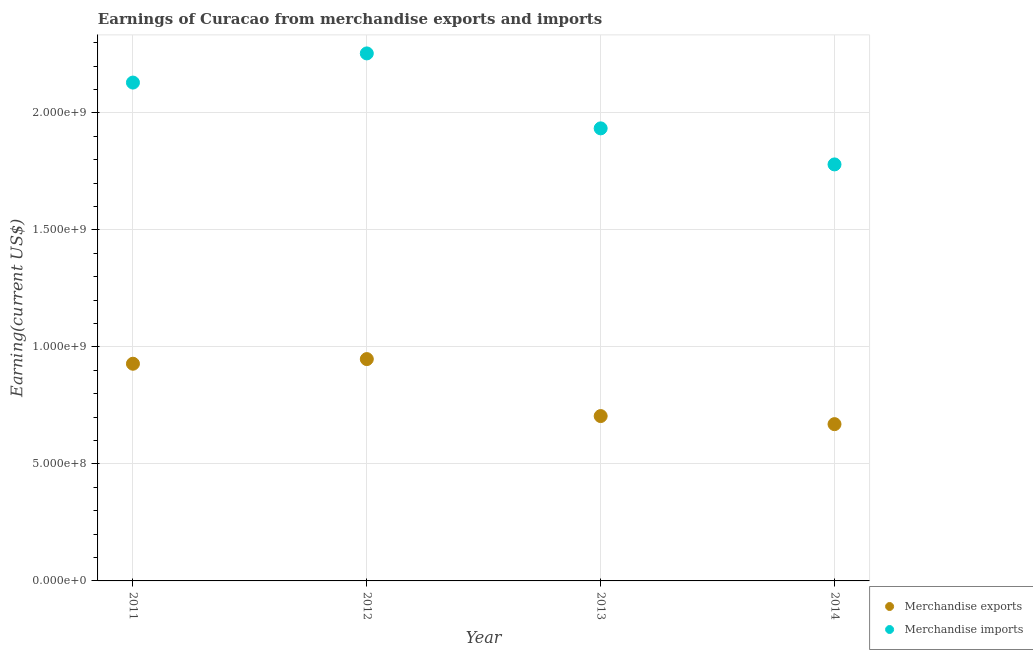What is the earnings from merchandise imports in 2012?
Your answer should be compact. 2.25e+09. Across all years, what is the maximum earnings from merchandise imports?
Make the answer very short. 2.25e+09. Across all years, what is the minimum earnings from merchandise exports?
Provide a succinct answer. 6.70e+08. In which year was the earnings from merchandise imports maximum?
Give a very brief answer. 2012. In which year was the earnings from merchandise imports minimum?
Offer a very short reply. 2014. What is the total earnings from merchandise imports in the graph?
Offer a terse response. 8.10e+09. What is the difference between the earnings from merchandise imports in 2012 and that in 2013?
Your answer should be very brief. 3.20e+08. What is the difference between the earnings from merchandise imports in 2014 and the earnings from merchandise exports in 2013?
Your answer should be very brief. 1.08e+09. What is the average earnings from merchandise imports per year?
Ensure brevity in your answer.  2.02e+09. In the year 2013, what is the difference between the earnings from merchandise imports and earnings from merchandise exports?
Offer a very short reply. 1.23e+09. What is the ratio of the earnings from merchandise imports in 2011 to that in 2012?
Give a very brief answer. 0.94. What is the difference between the highest and the second highest earnings from merchandise imports?
Ensure brevity in your answer.  1.25e+08. What is the difference between the highest and the lowest earnings from merchandise exports?
Keep it short and to the point. 2.78e+08. Does the earnings from merchandise exports monotonically increase over the years?
Keep it short and to the point. No. Is the earnings from merchandise exports strictly greater than the earnings from merchandise imports over the years?
Your response must be concise. No. How many years are there in the graph?
Provide a short and direct response. 4. What is the difference between two consecutive major ticks on the Y-axis?
Provide a short and direct response. 5.00e+08. Are the values on the major ticks of Y-axis written in scientific E-notation?
Your answer should be very brief. Yes. Does the graph contain any zero values?
Provide a succinct answer. No. Does the graph contain grids?
Provide a succinct answer. Yes. What is the title of the graph?
Your answer should be very brief. Earnings of Curacao from merchandise exports and imports. What is the label or title of the Y-axis?
Make the answer very short. Earning(current US$). What is the Earning(current US$) in Merchandise exports in 2011?
Make the answer very short. 9.28e+08. What is the Earning(current US$) of Merchandise imports in 2011?
Offer a very short reply. 2.13e+09. What is the Earning(current US$) in Merchandise exports in 2012?
Ensure brevity in your answer.  9.48e+08. What is the Earning(current US$) of Merchandise imports in 2012?
Keep it short and to the point. 2.25e+09. What is the Earning(current US$) of Merchandise exports in 2013?
Your answer should be very brief. 7.05e+08. What is the Earning(current US$) of Merchandise imports in 2013?
Your response must be concise. 1.93e+09. What is the Earning(current US$) of Merchandise exports in 2014?
Your answer should be very brief. 6.70e+08. What is the Earning(current US$) in Merchandise imports in 2014?
Provide a short and direct response. 1.78e+09. Across all years, what is the maximum Earning(current US$) of Merchandise exports?
Keep it short and to the point. 9.48e+08. Across all years, what is the maximum Earning(current US$) in Merchandise imports?
Provide a succinct answer. 2.25e+09. Across all years, what is the minimum Earning(current US$) of Merchandise exports?
Your response must be concise. 6.70e+08. Across all years, what is the minimum Earning(current US$) in Merchandise imports?
Offer a very short reply. 1.78e+09. What is the total Earning(current US$) in Merchandise exports in the graph?
Your answer should be compact. 3.25e+09. What is the total Earning(current US$) of Merchandise imports in the graph?
Your answer should be compact. 8.10e+09. What is the difference between the Earning(current US$) in Merchandise exports in 2011 and that in 2012?
Provide a short and direct response. -1.99e+07. What is the difference between the Earning(current US$) of Merchandise imports in 2011 and that in 2012?
Provide a succinct answer. -1.25e+08. What is the difference between the Earning(current US$) in Merchandise exports in 2011 and that in 2013?
Your answer should be very brief. 2.24e+08. What is the difference between the Earning(current US$) of Merchandise imports in 2011 and that in 2013?
Your answer should be compact. 1.96e+08. What is the difference between the Earning(current US$) in Merchandise exports in 2011 and that in 2014?
Provide a short and direct response. 2.58e+08. What is the difference between the Earning(current US$) in Merchandise imports in 2011 and that in 2014?
Provide a short and direct response. 3.50e+08. What is the difference between the Earning(current US$) in Merchandise exports in 2012 and that in 2013?
Give a very brief answer. 2.44e+08. What is the difference between the Earning(current US$) of Merchandise imports in 2012 and that in 2013?
Keep it short and to the point. 3.20e+08. What is the difference between the Earning(current US$) in Merchandise exports in 2012 and that in 2014?
Your answer should be very brief. 2.78e+08. What is the difference between the Earning(current US$) of Merchandise imports in 2012 and that in 2014?
Give a very brief answer. 4.74e+08. What is the difference between the Earning(current US$) of Merchandise exports in 2013 and that in 2014?
Give a very brief answer. 3.45e+07. What is the difference between the Earning(current US$) in Merchandise imports in 2013 and that in 2014?
Your response must be concise. 1.54e+08. What is the difference between the Earning(current US$) in Merchandise exports in 2011 and the Earning(current US$) in Merchandise imports in 2012?
Offer a very short reply. -1.33e+09. What is the difference between the Earning(current US$) of Merchandise exports in 2011 and the Earning(current US$) of Merchandise imports in 2013?
Keep it short and to the point. -1.01e+09. What is the difference between the Earning(current US$) of Merchandise exports in 2011 and the Earning(current US$) of Merchandise imports in 2014?
Ensure brevity in your answer.  -8.52e+08. What is the difference between the Earning(current US$) in Merchandise exports in 2012 and the Earning(current US$) in Merchandise imports in 2013?
Give a very brief answer. -9.86e+08. What is the difference between the Earning(current US$) of Merchandise exports in 2012 and the Earning(current US$) of Merchandise imports in 2014?
Your answer should be compact. -8.32e+08. What is the difference between the Earning(current US$) in Merchandise exports in 2013 and the Earning(current US$) in Merchandise imports in 2014?
Your answer should be compact. -1.08e+09. What is the average Earning(current US$) in Merchandise exports per year?
Provide a short and direct response. 8.13e+08. What is the average Earning(current US$) in Merchandise imports per year?
Your answer should be compact. 2.02e+09. In the year 2011, what is the difference between the Earning(current US$) in Merchandise exports and Earning(current US$) in Merchandise imports?
Your response must be concise. -1.20e+09. In the year 2012, what is the difference between the Earning(current US$) of Merchandise exports and Earning(current US$) of Merchandise imports?
Your response must be concise. -1.31e+09. In the year 2013, what is the difference between the Earning(current US$) of Merchandise exports and Earning(current US$) of Merchandise imports?
Provide a short and direct response. -1.23e+09. In the year 2014, what is the difference between the Earning(current US$) in Merchandise exports and Earning(current US$) in Merchandise imports?
Your answer should be compact. -1.11e+09. What is the ratio of the Earning(current US$) of Merchandise imports in 2011 to that in 2012?
Provide a short and direct response. 0.94. What is the ratio of the Earning(current US$) in Merchandise exports in 2011 to that in 2013?
Provide a short and direct response. 1.32. What is the ratio of the Earning(current US$) in Merchandise imports in 2011 to that in 2013?
Offer a terse response. 1.1. What is the ratio of the Earning(current US$) of Merchandise exports in 2011 to that in 2014?
Your response must be concise. 1.39. What is the ratio of the Earning(current US$) of Merchandise imports in 2011 to that in 2014?
Give a very brief answer. 1.2. What is the ratio of the Earning(current US$) in Merchandise exports in 2012 to that in 2013?
Your response must be concise. 1.35. What is the ratio of the Earning(current US$) of Merchandise imports in 2012 to that in 2013?
Give a very brief answer. 1.17. What is the ratio of the Earning(current US$) in Merchandise exports in 2012 to that in 2014?
Give a very brief answer. 1.42. What is the ratio of the Earning(current US$) of Merchandise imports in 2012 to that in 2014?
Your answer should be very brief. 1.27. What is the ratio of the Earning(current US$) in Merchandise exports in 2013 to that in 2014?
Make the answer very short. 1.05. What is the ratio of the Earning(current US$) in Merchandise imports in 2013 to that in 2014?
Keep it short and to the point. 1.09. What is the difference between the highest and the second highest Earning(current US$) in Merchandise exports?
Your answer should be compact. 1.99e+07. What is the difference between the highest and the second highest Earning(current US$) of Merchandise imports?
Provide a succinct answer. 1.25e+08. What is the difference between the highest and the lowest Earning(current US$) in Merchandise exports?
Keep it short and to the point. 2.78e+08. What is the difference between the highest and the lowest Earning(current US$) in Merchandise imports?
Your answer should be compact. 4.74e+08. 